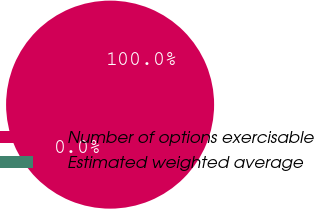<chart> <loc_0><loc_0><loc_500><loc_500><pie_chart><fcel>Number of options exercisable<fcel>Estimated weighted average<nl><fcel>100.0%<fcel>0.0%<nl></chart> 